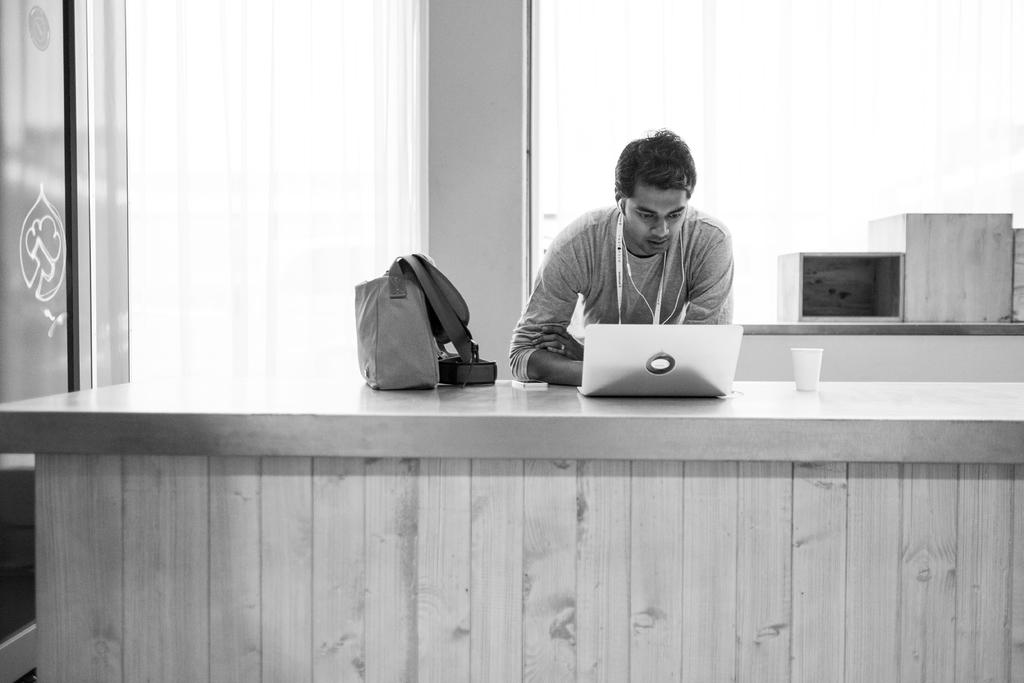Who or what is in the image? There is a person in the image. What is the person doing in the image? The person is leaning on a table. What objects are on the table in the image? The table has a laptop, a bag, a mobile, and a glass on it. What can be seen in the background of the image? There is a window in the background of the image. What is in front of the window in the image? There are boxes in front of the window. What type of wood can be seen in the image? There is no wood visible in the image. How many geese are present in the image? There are no geese present in the image. 